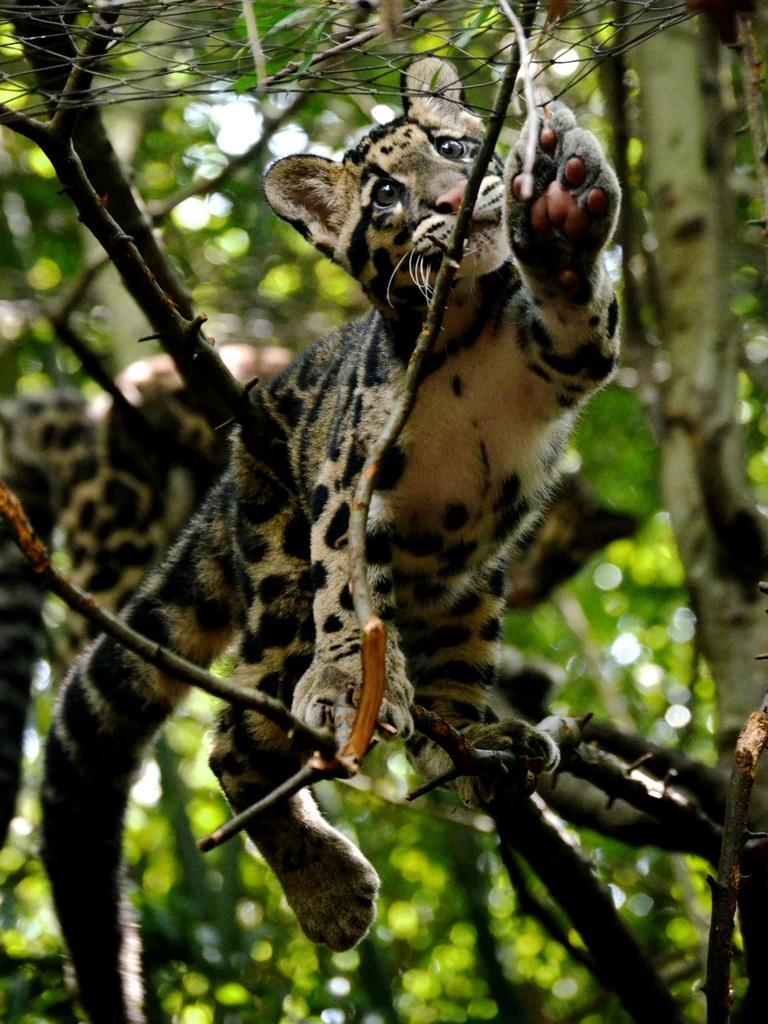How would you summarize this image in a sentence or two? There is an animal on the tree presenting in this picture. 